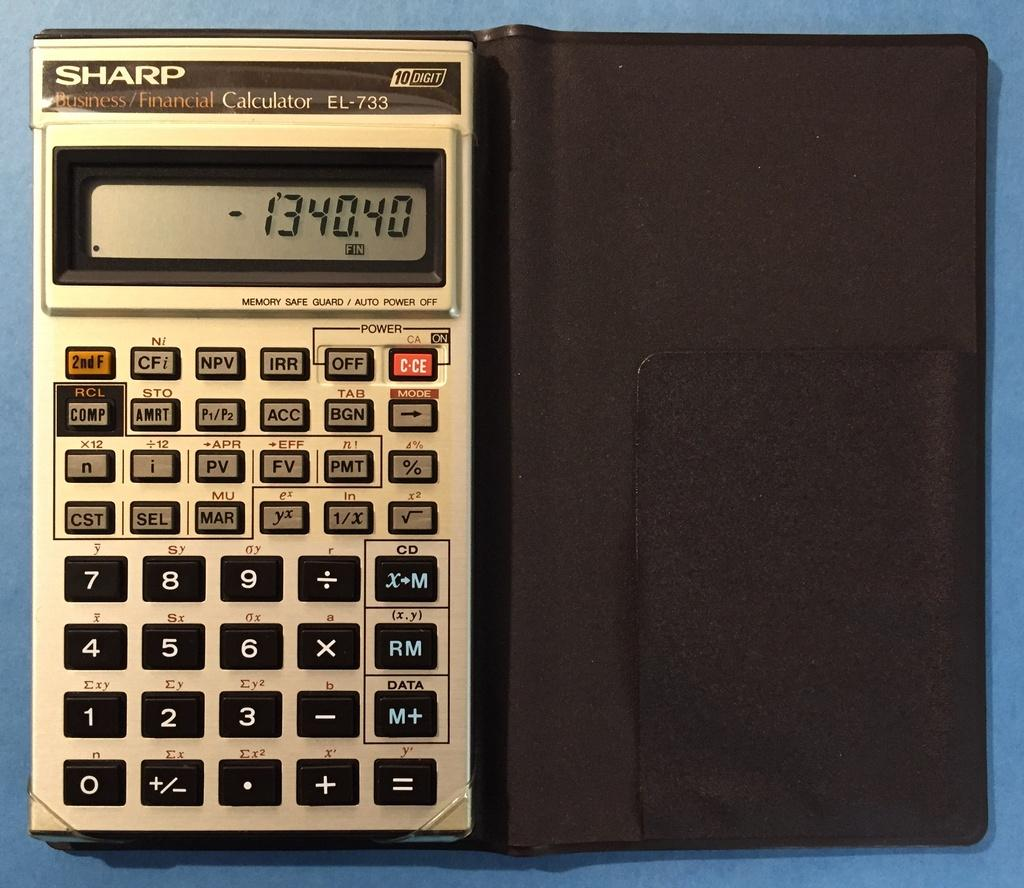What is the main object in the center of the image? There is a calculator in the center of the image. What can be seen in the background of the image? There is a table in the background of the image. How many fish are swimming in the image? There are no fish present in the image. What type of tree can be seen in the image? There is no tree present in the image. 